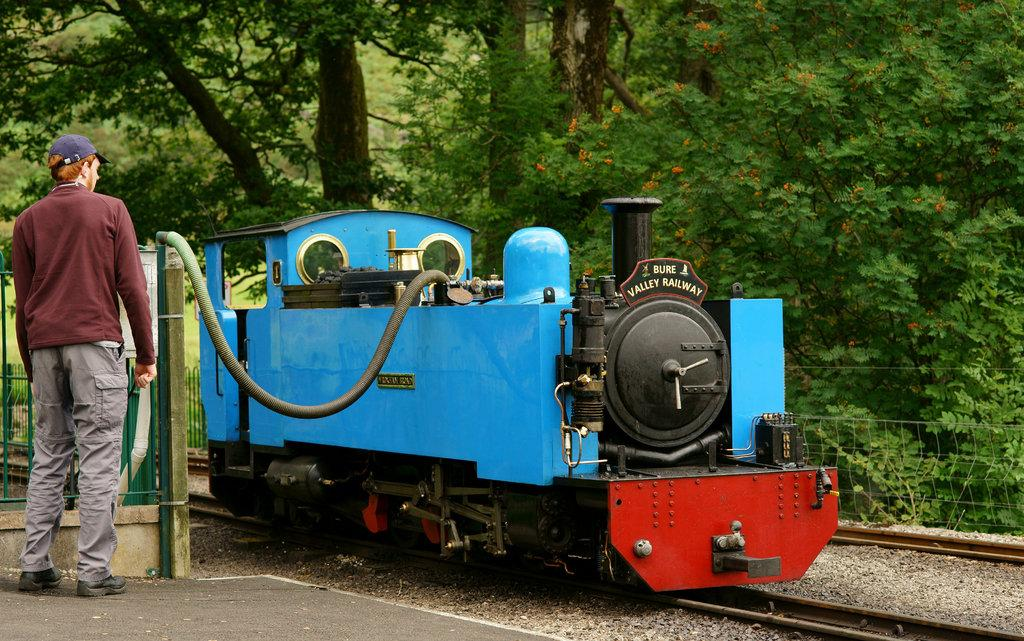What is the main subject of the image? The main subject of the image is a train engine. Where is the train engine located? The train engine is on a railway track. Can you describe the person in the image? There is a person standing in the image. What can be seen in the background of the image? There are trees in the background of the image. What type of silk fabric is draped over the furniture in the image? There is no silk fabric or furniture present in the image; it features a train engine on a railway track with a person standing nearby and trees in the background. 